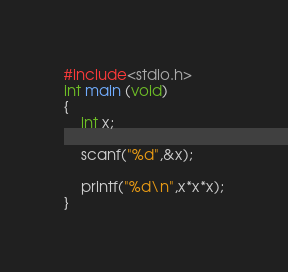Convert code to text. <code><loc_0><loc_0><loc_500><loc_500><_C_>#include<stdio.h>
int main (void)
{
	int x;
	
	scanf("%d",&x);
	
	printf("%d\n",x*x*x);
}</code> 